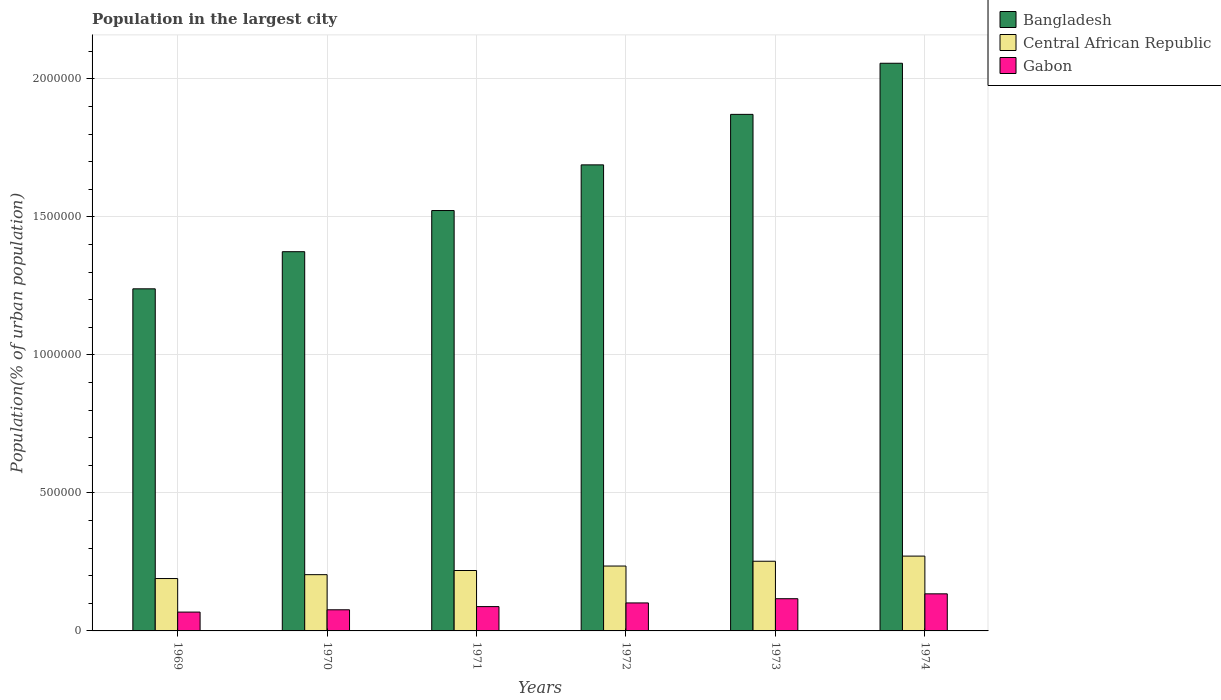How many groups of bars are there?
Your answer should be compact. 6. Are the number of bars per tick equal to the number of legend labels?
Make the answer very short. Yes. Are the number of bars on each tick of the X-axis equal?
Offer a very short reply. Yes. How many bars are there on the 1st tick from the left?
Offer a terse response. 3. What is the label of the 3rd group of bars from the left?
Your answer should be very brief. 1971. In how many cases, is the number of bars for a given year not equal to the number of legend labels?
Provide a succinct answer. 0. What is the population in the largest city in Gabon in 1970?
Your answer should be compact. 7.66e+04. Across all years, what is the maximum population in the largest city in Central African Republic?
Make the answer very short. 2.71e+05. Across all years, what is the minimum population in the largest city in Bangladesh?
Your response must be concise. 1.24e+06. In which year was the population in the largest city in Central African Republic maximum?
Your answer should be compact. 1974. In which year was the population in the largest city in Bangladesh minimum?
Your response must be concise. 1969. What is the total population in the largest city in Central African Republic in the graph?
Offer a terse response. 1.37e+06. What is the difference between the population in the largest city in Central African Republic in 1969 and that in 1972?
Keep it short and to the point. -4.53e+04. What is the difference between the population in the largest city in Gabon in 1970 and the population in the largest city in Central African Republic in 1971?
Provide a succinct answer. -1.42e+05. What is the average population in the largest city in Central African Republic per year?
Provide a short and direct response. 2.28e+05. In the year 1973, what is the difference between the population in the largest city in Gabon and population in the largest city in Bangladesh?
Your answer should be compact. -1.75e+06. In how many years, is the population in the largest city in Bangladesh greater than 100000 %?
Make the answer very short. 6. What is the ratio of the population in the largest city in Bangladesh in 1972 to that in 1974?
Your answer should be very brief. 0.82. Is the population in the largest city in Gabon in 1972 less than that in 1974?
Your response must be concise. Yes. What is the difference between the highest and the second highest population in the largest city in Central African Republic?
Provide a short and direct response. 1.87e+04. What is the difference between the highest and the lowest population in the largest city in Bangladesh?
Offer a very short reply. 8.17e+05. In how many years, is the population in the largest city in Bangladesh greater than the average population in the largest city in Bangladesh taken over all years?
Provide a short and direct response. 3. Is the sum of the population in the largest city in Central African Republic in 1971 and 1974 greater than the maximum population in the largest city in Gabon across all years?
Provide a short and direct response. Yes. What does the 3rd bar from the left in 1970 represents?
Make the answer very short. Gabon. What does the 2nd bar from the right in 1974 represents?
Your answer should be compact. Central African Republic. Is it the case that in every year, the sum of the population in the largest city in Central African Republic and population in the largest city in Gabon is greater than the population in the largest city in Bangladesh?
Give a very brief answer. No. How many bars are there?
Keep it short and to the point. 18. Are all the bars in the graph horizontal?
Give a very brief answer. No. How many years are there in the graph?
Offer a very short reply. 6. Does the graph contain any zero values?
Provide a succinct answer. No. Does the graph contain grids?
Make the answer very short. Yes. What is the title of the graph?
Give a very brief answer. Population in the largest city. What is the label or title of the Y-axis?
Your response must be concise. Population(% of urban population). What is the Population(% of urban population) of Bangladesh in 1969?
Keep it short and to the point. 1.24e+06. What is the Population(% of urban population) of Central African Republic in 1969?
Ensure brevity in your answer.  1.90e+05. What is the Population(% of urban population) in Gabon in 1969?
Your answer should be compact. 6.82e+04. What is the Population(% of urban population) in Bangladesh in 1970?
Offer a terse response. 1.37e+06. What is the Population(% of urban population) of Central African Republic in 1970?
Provide a succinct answer. 2.04e+05. What is the Population(% of urban population) of Gabon in 1970?
Make the answer very short. 7.66e+04. What is the Population(% of urban population) of Bangladesh in 1971?
Offer a very short reply. 1.52e+06. What is the Population(% of urban population) of Central African Republic in 1971?
Your response must be concise. 2.19e+05. What is the Population(% of urban population) in Gabon in 1971?
Your response must be concise. 8.81e+04. What is the Population(% of urban population) of Bangladesh in 1972?
Provide a short and direct response. 1.69e+06. What is the Population(% of urban population) of Central African Republic in 1972?
Offer a terse response. 2.35e+05. What is the Population(% of urban population) of Gabon in 1972?
Keep it short and to the point. 1.01e+05. What is the Population(% of urban population) of Bangladesh in 1973?
Give a very brief answer. 1.87e+06. What is the Population(% of urban population) of Central African Republic in 1973?
Ensure brevity in your answer.  2.52e+05. What is the Population(% of urban population) in Gabon in 1973?
Your answer should be compact. 1.17e+05. What is the Population(% of urban population) in Bangladesh in 1974?
Offer a terse response. 2.06e+06. What is the Population(% of urban population) of Central African Republic in 1974?
Ensure brevity in your answer.  2.71e+05. What is the Population(% of urban population) of Gabon in 1974?
Your response must be concise. 1.34e+05. Across all years, what is the maximum Population(% of urban population) in Bangladesh?
Offer a very short reply. 2.06e+06. Across all years, what is the maximum Population(% of urban population) of Central African Republic?
Your response must be concise. 2.71e+05. Across all years, what is the maximum Population(% of urban population) in Gabon?
Your answer should be compact. 1.34e+05. Across all years, what is the minimum Population(% of urban population) in Bangladesh?
Your response must be concise. 1.24e+06. Across all years, what is the minimum Population(% of urban population) in Central African Republic?
Your answer should be compact. 1.90e+05. Across all years, what is the minimum Population(% of urban population) in Gabon?
Make the answer very short. 6.82e+04. What is the total Population(% of urban population) in Bangladesh in the graph?
Keep it short and to the point. 9.75e+06. What is the total Population(% of urban population) in Central African Republic in the graph?
Provide a short and direct response. 1.37e+06. What is the total Population(% of urban population) in Gabon in the graph?
Offer a very short reply. 5.85e+05. What is the difference between the Population(% of urban population) in Bangladesh in 1969 and that in 1970?
Offer a terse response. -1.34e+05. What is the difference between the Population(% of urban population) in Central African Republic in 1969 and that in 1970?
Ensure brevity in your answer.  -1.40e+04. What is the difference between the Population(% of urban population) in Gabon in 1969 and that in 1970?
Provide a succinct answer. -8327. What is the difference between the Population(% of urban population) of Bangladesh in 1969 and that in 1971?
Provide a succinct answer. -2.84e+05. What is the difference between the Population(% of urban population) of Central African Republic in 1969 and that in 1971?
Offer a very short reply. -2.91e+04. What is the difference between the Population(% of urban population) of Gabon in 1969 and that in 1971?
Keep it short and to the point. -1.99e+04. What is the difference between the Population(% of urban population) of Bangladesh in 1969 and that in 1972?
Your answer should be compact. -4.49e+05. What is the difference between the Population(% of urban population) of Central African Republic in 1969 and that in 1972?
Your answer should be very brief. -4.53e+04. What is the difference between the Population(% of urban population) in Gabon in 1969 and that in 1972?
Provide a short and direct response. -3.32e+04. What is the difference between the Population(% of urban population) of Bangladesh in 1969 and that in 1973?
Your response must be concise. -6.32e+05. What is the difference between the Population(% of urban population) of Central African Republic in 1969 and that in 1973?
Provide a short and direct response. -6.26e+04. What is the difference between the Population(% of urban population) of Gabon in 1969 and that in 1973?
Keep it short and to the point. -4.85e+04. What is the difference between the Population(% of urban population) of Bangladesh in 1969 and that in 1974?
Your answer should be compact. -8.17e+05. What is the difference between the Population(% of urban population) in Central African Republic in 1969 and that in 1974?
Ensure brevity in your answer.  -8.13e+04. What is the difference between the Population(% of urban population) in Gabon in 1969 and that in 1974?
Ensure brevity in your answer.  -6.61e+04. What is the difference between the Population(% of urban population) in Bangladesh in 1970 and that in 1971?
Offer a very short reply. -1.49e+05. What is the difference between the Population(% of urban population) of Central African Republic in 1970 and that in 1971?
Make the answer very short. -1.51e+04. What is the difference between the Population(% of urban population) in Gabon in 1970 and that in 1971?
Give a very brief answer. -1.16e+04. What is the difference between the Population(% of urban population) of Bangladesh in 1970 and that in 1972?
Your response must be concise. -3.15e+05. What is the difference between the Population(% of urban population) of Central African Republic in 1970 and that in 1972?
Offer a terse response. -3.13e+04. What is the difference between the Population(% of urban population) of Gabon in 1970 and that in 1972?
Your answer should be compact. -2.49e+04. What is the difference between the Population(% of urban population) in Bangladesh in 1970 and that in 1973?
Your response must be concise. -4.97e+05. What is the difference between the Population(% of urban population) of Central African Republic in 1970 and that in 1973?
Make the answer very short. -4.86e+04. What is the difference between the Population(% of urban population) in Gabon in 1970 and that in 1973?
Offer a terse response. -4.02e+04. What is the difference between the Population(% of urban population) in Bangladesh in 1970 and that in 1974?
Offer a very short reply. -6.83e+05. What is the difference between the Population(% of urban population) in Central African Republic in 1970 and that in 1974?
Provide a short and direct response. -6.73e+04. What is the difference between the Population(% of urban population) in Gabon in 1970 and that in 1974?
Ensure brevity in your answer.  -5.78e+04. What is the difference between the Population(% of urban population) of Bangladesh in 1971 and that in 1972?
Make the answer very short. -1.65e+05. What is the difference between the Population(% of urban population) in Central African Republic in 1971 and that in 1972?
Make the answer very short. -1.62e+04. What is the difference between the Population(% of urban population) in Gabon in 1971 and that in 1972?
Offer a very short reply. -1.33e+04. What is the difference between the Population(% of urban population) of Bangladesh in 1971 and that in 1973?
Give a very brief answer. -3.48e+05. What is the difference between the Population(% of urban population) of Central African Republic in 1971 and that in 1973?
Your answer should be very brief. -3.35e+04. What is the difference between the Population(% of urban population) in Gabon in 1971 and that in 1973?
Provide a succinct answer. -2.86e+04. What is the difference between the Population(% of urban population) of Bangladesh in 1971 and that in 1974?
Ensure brevity in your answer.  -5.34e+05. What is the difference between the Population(% of urban population) in Central African Republic in 1971 and that in 1974?
Make the answer very short. -5.22e+04. What is the difference between the Population(% of urban population) of Gabon in 1971 and that in 1974?
Keep it short and to the point. -4.62e+04. What is the difference between the Population(% of urban population) in Bangladesh in 1972 and that in 1973?
Provide a short and direct response. -1.83e+05. What is the difference between the Population(% of urban population) of Central African Republic in 1972 and that in 1973?
Make the answer very short. -1.73e+04. What is the difference between the Population(% of urban population) in Gabon in 1972 and that in 1973?
Keep it short and to the point. -1.53e+04. What is the difference between the Population(% of urban population) in Bangladesh in 1972 and that in 1974?
Ensure brevity in your answer.  -3.68e+05. What is the difference between the Population(% of urban population) of Central African Republic in 1972 and that in 1974?
Keep it short and to the point. -3.60e+04. What is the difference between the Population(% of urban population) of Gabon in 1972 and that in 1974?
Make the answer very short. -3.29e+04. What is the difference between the Population(% of urban population) of Bangladesh in 1973 and that in 1974?
Keep it short and to the point. -1.85e+05. What is the difference between the Population(% of urban population) of Central African Republic in 1973 and that in 1974?
Your response must be concise. -1.87e+04. What is the difference between the Population(% of urban population) in Gabon in 1973 and that in 1974?
Keep it short and to the point. -1.76e+04. What is the difference between the Population(% of urban population) of Bangladesh in 1969 and the Population(% of urban population) of Central African Republic in 1970?
Keep it short and to the point. 1.04e+06. What is the difference between the Population(% of urban population) of Bangladesh in 1969 and the Population(% of urban population) of Gabon in 1970?
Your answer should be very brief. 1.16e+06. What is the difference between the Population(% of urban population) in Central African Republic in 1969 and the Population(% of urban population) in Gabon in 1970?
Offer a terse response. 1.13e+05. What is the difference between the Population(% of urban population) of Bangladesh in 1969 and the Population(% of urban population) of Central African Republic in 1971?
Your response must be concise. 1.02e+06. What is the difference between the Population(% of urban population) of Bangladesh in 1969 and the Population(% of urban population) of Gabon in 1971?
Provide a short and direct response. 1.15e+06. What is the difference between the Population(% of urban population) of Central African Republic in 1969 and the Population(% of urban population) of Gabon in 1971?
Ensure brevity in your answer.  1.02e+05. What is the difference between the Population(% of urban population) in Bangladesh in 1969 and the Population(% of urban population) in Central African Republic in 1972?
Provide a short and direct response. 1.00e+06. What is the difference between the Population(% of urban population) of Bangladesh in 1969 and the Population(% of urban population) of Gabon in 1972?
Offer a terse response. 1.14e+06. What is the difference between the Population(% of urban population) of Central African Republic in 1969 and the Population(% of urban population) of Gabon in 1972?
Give a very brief answer. 8.83e+04. What is the difference between the Population(% of urban population) in Bangladesh in 1969 and the Population(% of urban population) in Central African Republic in 1973?
Your answer should be compact. 9.87e+05. What is the difference between the Population(% of urban population) in Bangladesh in 1969 and the Population(% of urban population) in Gabon in 1973?
Ensure brevity in your answer.  1.12e+06. What is the difference between the Population(% of urban population) in Central African Republic in 1969 and the Population(% of urban population) in Gabon in 1973?
Your answer should be compact. 7.30e+04. What is the difference between the Population(% of urban population) in Bangladesh in 1969 and the Population(% of urban population) in Central African Republic in 1974?
Offer a very short reply. 9.68e+05. What is the difference between the Population(% of urban population) of Bangladesh in 1969 and the Population(% of urban population) of Gabon in 1974?
Offer a very short reply. 1.10e+06. What is the difference between the Population(% of urban population) in Central African Republic in 1969 and the Population(% of urban population) in Gabon in 1974?
Your response must be concise. 5.54e+04. What is the difference between the Population(% of urban population) in Bangladesh in 1970 and the Population(% of urban population) in Central African Republic in 1971?
Your answer should be compact. 1.15e+06. What is the difference between the Population(% of urban population) in Bangladesh in 1970 and the Population(% of urban population) in Gabon in 1971?
Make the answer very short. 1.29e+06. What is the difference between the Population(% of urban population) in Central African Republic in 1970 and the Population(% of urban population) in Gabon in 1971?
Make the answer very short. 1.16e+05. What is the difference between the Population(% of urban population) in Bangladesh in 1970 and the Population(% of urban population) in Central African Republic in 1972?
Offer a terse response. 1.14e+06. What is the difference between the Population(% of urban population) of Bangladesh in 1970 and the Population(% of urban population) of Gabon in 1972?
Ensure brevity in your answer.  1.27e+06. What is the difference between the Population(% of urban population) in Central African Republic in 1970 and the Population(% of urban population) in Gabon in 1972?
Offer a very short reply. 1.02e+05. What is the difference between the Population(% of urban population) in Bangladesh in 1970 and the Population(% of urban population) in Central African Republic in 1973?
Provide a succinct answer. 1.12e+06. What is the difference between the Population(% of urban population) in Bangladesh in 1970 and the Population(% of urban population) in Gabon in 1973?
Provide a succinct answer. 1.26e+06. What is the difference between the Population(% of urban population) in Central African Republic in 1970 and the Population(% of urban population) in Gabon in 1973?
Your answer should be compact. 8.71e+04. What is the difference between the Population(% of urban population) of Bangladesh in 1970 and the Population(% of urban population) of Central African Republic in 1974?
Provide a short and direct response. 1.10e+06. What is the difference between the Population(% of urban population) of Bangladesh in 1970 and the Population(% of urban population) of Gabon in 1974?
Offer a terse response. 1.24e+06. What is the difference between the Population(% of urban population) in Central African Republic in 1970 and the Population(% of urban population) in Gabon in 1974?
Provide a succinct answer. 6.95e+04. What is the difference between the Population(% of urban population) of Bangladesh in 1971 and the Population(% of urban population) of Central African Republic in 1972?
Your answer should be compact. 1.29e+06. What is the difference between the Population(% of urban population) of Bangladesh in 1971 and the Population(% of urban population) of Gabon in 1972?
Ensure brevity in your answer.  1.42e+06. What is the difference between the Population(% of urban population) in Central African Republic in 1971 and the Population(% of urban population) in Gabon in 1972?
Offer a terse response. 1.17e+05. What is the difference between the Population(% of urban population) of Bangladesh in 1971 and the Population(% of urban population) of Central African Republic in 1973?
Ensure brevity in your answer.  1.27e+06. What is the difference between the Population(% of urban population) of Bangladesh in 1971 and the Population(% of urban population) of Gabon in 1973?
Keep it short and to the point. 1.41e+06. What is the difference between the Population(% of urban population) of Central African Republic in 1971 and the Population(% of urban population) of Gabon in 1973?
Ensure brevity in your answer.  1.02e+05. What is the difference between the Population(% of urban population) in Bangladesh in 1971 and the Population(% of urban population) in Central African Republic in 1974?
Offer a very short reply. 1.25e+06. What is the difference between the Population(% of urban population) in Bangladesh in 1971 and the Population(% of urban population) in Gabon in 1974?
Your response must be concise. 1.39e+06. What is the difference between the Population(% of urban population) of Central African Republic in 1971 and the Population(% of urban population) of Gabon in 1974?
Provide a succinct answer. 8.45e+04. What is the difference between the Population(% of urban population) of Bangladesh in 1972 and the Population(% of urban population) of Central African Republic in 1973?
Your answer should be very brief. 1.44e+06. What is the difference between the Population(% of urban population) in Bangladesh in 1972 and the Population(% of urban population) in Gabon in 1973?
Your response must be concise. 1.57e+06. What is the difference between the Population(% of urban population) of Central African Republic in 1972 and the Population(% of urban population) of Gabon in 1973?
Your answer should be very brief. 1.18e+05. What is the difference between the Population(% of urban population) of Bangladesh in 1972 and the Population(% of urban population) of Central African Republic in 1974?
Your response must be concise. 1.42e+06. What is the difference between the Population(% of urban population) of Bangladesh in 1972 and the Population(% of urban population) of Gabon in 1974?
Provide a succinct answer. 1.55e+06. What is the difference between the Population(% of urban population) of Central African Republic in 1972 and the Population(% of urban population) of Gabon in 1974?
Make the answer very short. 1.01e+05. What is the difference between the Population(% of urban population) in Bangladesh in 1973 and the Population(% of urban population) in Central African Republic in 1974?
Provide a short and direct response. 1.60e+06. What is the difference between the Population(% of urban population) in Bangladesh in 1973 and the Population(% of urban population) in Gabon in 1974?
Give a very brief answer. 1.74e+06. What is the difference between the Population(% of urban population) in Central African Republic in 1973 and the Population(% of urban population) in Gabon in 1974?
Ensure brevity in your answer.  1.18e+05. What is the average Population(% of urban population) of Bangladesh per year?
Give a very brief answer. 1.63e+06. What is the average Population(% of urban population) of Central African Republic per year?
Your response must be concise. 2.28e+05. What is the average Population(% of urban population) in Gabon per year?
Ensure brevity in your answer.  9.76e+04. In the year 1969, what is the difference between the Population(% of urban population) in Bangladesh and Population(% of urban population) in Central African Republic?
Offer a very short reply. 1.05e+06. In the year 1969, what is the difference between the Population(% of urban population) in Bangladesh and Population(% of urban population) in Gabon?
Keep it short and to the point. 1.17e+06. In the year 1969, what is the difference between the Population(% of urban population) in Central African Republic and Population(% of urban population) in Gabon?
Your answer should be compact. 1.22e+05. In the year 1970, what is the difference between the Population(% of urban population) of Bangladesh and Population(% of urban population) of Central African Republic?
Offer a terse response. 1.17e+06. In the year 1970, what is the difference between the Population(% of urban population) in Bangladesh and Population(% of urban population) in Gabon?
Your answer should be very brief. 1.30e+06. In the year 1970, what is the difference between the Population(% of urban population) of Central African Republic and Population(% of urban population) of Gabon?
Keep it short and to the point. 1.27e+05. In the year 1971, what is the difference between the Population(% of urban population) in Bangladesh and Population(% of urban population) in Central African Republic?
Provide a succinct answer. 1.30e+06. In the year 1971, what is the difference between the Population(% of urban population) in Bangladesh and Population(% of urban population) in Gabon?
Your response must be concise. 1.43e+06. In the year 1971, what is the difference between the Population(% of urban population) in Central African Republic and Population(% of urban population) in Gabon?
Keep it short and to the point. 1.31e+05. In the year 1972, what is the difference between the Population(% of urban population) of Bangladesh and Population(% of urban population) of Central African Republic?
Give a very brief answer. 1.45e+06. In the year 1972, what is the difference between the Population(% of urban population) in Bangladesh and Population(% of urban population) in Gabon?
Your response must be concise. 1.59e+06. In the year 1972, what is the difference between the Population(% of urban population) in Central African Republic and Population(% of urban population) in Gabon?
Provide a succinct answer. 1.34e+05. In the year 1973, what is the difference between the Population(% of urban population) in Bangladesh and Population(% of urban population) in Central African Republic?
Your response must be concise. 1.62e+06. In the year 1973, what is the difference between the Population(% of urban population) of Bangladesh and Population(% of urban population) of Gabon?
Give a very brief answer. 1.75e+06. In the year 1973, what is the difference between the Population(% of urban population) in Central African Republic and Population(% of urban population) in Gabon?
Provide a succinct answer. 1.36e+05. In the year 1974, what is the difference between the Population(% of urban population) of Bangladesh and Population(% of urban population) of Central African Republic?
Provide a short and direct response. 1.79e+06. In the year 1974, what is the difference between the Population(% of urban population) in Bangladesh and Population(% of urban population) in Gabon?
Provide a short and direct response. 1.92e+06. In the year 1974, what is the difference between the Population(% of urban population) in Central African Republic and Population(% of urban population) in Gabon?
Give a very brief answer. 1.37e+05. What is the ratio of the Population(% of urban population) in Bangladesh in 1969 to that in 1970?
Ensure brevity in your answer.  0.9. What is the ratio of the Population(% of urban population) of Central African Republic in 1969 to that in 1970?
Give a very brief answer. 0.93. What is the ratio of the Population(% of urban population) of Gabon in 1969 to that in 1970?
Your response must be concise. 0.89. What is the ratio of the Population(% of urban population) of Bangladesh in 1969 to that in 1971?
Your answer should be very brief. 0.81. What is the ratio of the Population(% of urban population) of Central African Republic in 1969 to that in 1971?
Make the answer very short. 0.87. What is the ratio of the Population(% of urban population) of Gabon in 1969 to that in 1971?
Offer a very short reply. 0.77. What is the ratio of the Population(% of urban population) in Bangladesh in 1969 to that in 1972?
Provide a succinct answer. 0.73. What is the ratio of the Population(% of urban population) in Central African Republic in 1969 to that in 1972?
Keep it short and to the point. 0.81. What is the ratio of the Population(% of urban population) of Gabon in 1969 to that in 1972?
Provide a short and direct response. 0.67. What is the ratio of the Population(% of urban population) in Bangladesh in 1969 to that in 1973?
Offer a very short reply. 0.66. What is the ratio of the Population(% of urban population) in Central African Republic in 1969 to that in 1973?
Offer a terse response. 0.75. What is the ratio of the Population(% of urban population) in Gabon in 1969 to that in 1973?
Provide a short and direct response. 0.58. What is the ratio of the Population(% of urban population) of Bangladesh in 1969 to that in 1974?
Keep it short and to the point. 0.6. What is the ratio of the Population(% of urban population) of Central African Republic in 1969 to that in 1974?
Offer a very short reply. 0.7. What is the ratio of the Population(% of urban population) in Gabon in 1969 to that in 1974?
Your response must be concise. 0.51. What is the ratio of the Population(% of urban population) in Bangladesh in 1970 to that in 1971?
Your answer should be compact. 0.9. What is the ratio of the Population(% of urban population) in Central African Republic in 1970 to that in 1971?
Keep it short and to the point. 0.93. What is the ratio of the Population(% of urban population) in Gabon in 1970 to that in 1971?
Offer a very short reply. 0.87. What is the ratio of the Population(% of urban population) in Bangladesh in 1970 to that in 1972?
Give a very brief answer. 0.81. What is the ratio of the Population(% of urban population) of Central African Republic in 1970 to that in 1972?
Your answer should be very brief. 0.87. What is the ratio of the Population(% of urban population) of Gabon in 1970 to that in 1972?
Your answer should be very brief. 0.75. What is the ratio of the Population(% of urban population) in Bangladesh in 1970 to that in 1973?
Provide a succinct answer. 0.73. What is the ratio of the Population(% of urban population) of Central African Republic in 1970 to that in 1973?
Give a very brief answer. 0.81. What is the ratio of the Population(% of urban population) of Gabon in 1970 to that in 1973?
Give a very brief answer. 0.66. What is the ratio of the Population(% of urban population) in Bangladesh in 1970 to that in 1974?
Make the answer very short. 0.67. What is the ratio of the Population(% of urban population) of Central African Republic in 1970 to that in 1974?
Provide a succinct answer. 0.75. What is the ratio of the Population(% of urban population) of Gabon in 1970 to that in 1974?
Provide a short and direct response. 0.57. What is the ratio of the Population(% of urban population) of Bangladesh in 1971 to that in 1972?
Offer a very short reply. 0.9. What is the ratio of the Population(% of urban population) in Central African Republic in 1971 to that in 1972?
Offer a terse response. 0.93. What is the ratio of the Population(% of urban population) in Gabon in 1971 to that in 1972?
Ensure brevity in your answer.  0.87. What is the ratio of the Population(% of urban population) of Bangladesh in 1971 to that in 1973?
Give a very brief answer. 0.81. What is the ratio of the Population(% of urban population) in Central African Republic in 1971 to that in 1973?
Your answer should be very brief. 0.87. What is the ratio of the Population(% of urban population) of Gabon in 1971 to that in 1973?
Your answer should be very brief. 0.75. What is the ratio of the Population(% of urban population) of Bangladesh in 1971 to that in 1974?
Provide a short and direct response. 0.74. What is the ratio of the Population(% of urban population) of Central African Republic in 1971 to that in 1974?
Make the answer very short. 0.81. What is the ratio of the Population(% of urban population) of Gabon in 1971 to that in 1974?
Provide a succinct answer. 0.66. What is the ratio of the Population(% of urban population) in Bangladesh in 1972 to that in 1973?
Provide a succinct answer. 0.9. What is the ratio of the Population(% of urban population) of Central African Republic in 1972 to that in 1973?
Make the answer very short. 0.93. What is the ratio of the Population(% of urban population) of Gabon in 1972 to that in 1973?
Ensure brevity in your answer.  0.87. What is the ratio of the Population(% of urban population) of Bangladesh in 1972 to that in 1974?
Your answer should be compact. 0.82. What is the ratio of the Population(% of urban population) in Central African Republic in 1972 to that in 1974?
Your response must be concise. 0.87. What is the ratio of the Population(% of urban population) in Gabon in 1972 to that in 1974?
Provide a succinct answer. 0.76. What is the ratio of the Population(% of urban population) of Bangladesh in 1973 to that in 1974?
Make the answer very short. 0.91. What is the ratio of the Population(% of urban population) of Central African Republic in 1973 to that in 1974?
Provide a succinct answer. 0.93. What is the ratio of the Population(% of urban population) in Gabon in 1973 to that in 1974?
Offer a terse response. 0.87. What is the difference between the highest and the second highest Population(% of urban population) in Bangladesh?
Your answer should be compact. 1.85e+05. What is the difference between the highest and the second highest Population(% of urban population) in Central African Republic?
Your answer should be very brief. 1.87e+04. What is the difference between the highest and the second highest Population(% of urban population) of Gabon?
Provide a succinct answer. 1.76e+04. What is the difference between the highest and the lowest Population(% of urban population) in Bangladesh?
Ensure brevity in your answer.  8.17e+05. What is the difference between the highest and the lowest Population(% of urban population) in Central African Republic?
Your response must be concise. 8.13e+04. What is the difference between the highest and the lowest Population(% of urban population) of Gabon?
Your answer should be compact. 6.61e+04. 